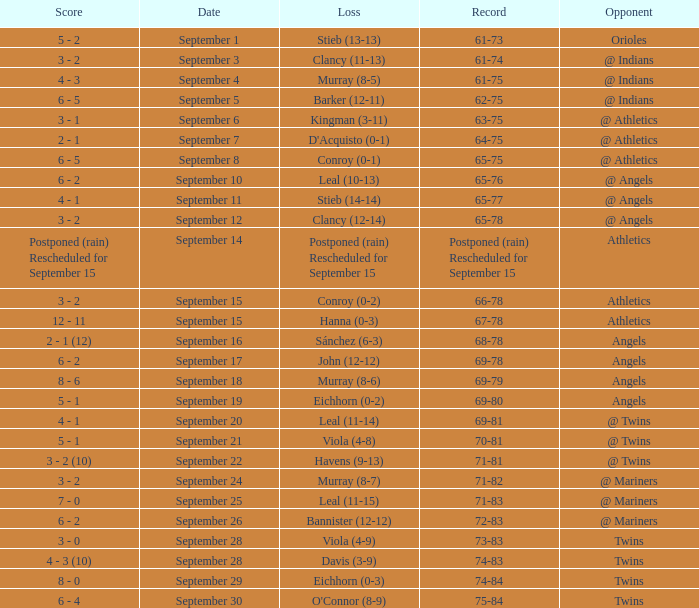Name the score which has record of 73-83 3 - 0. 